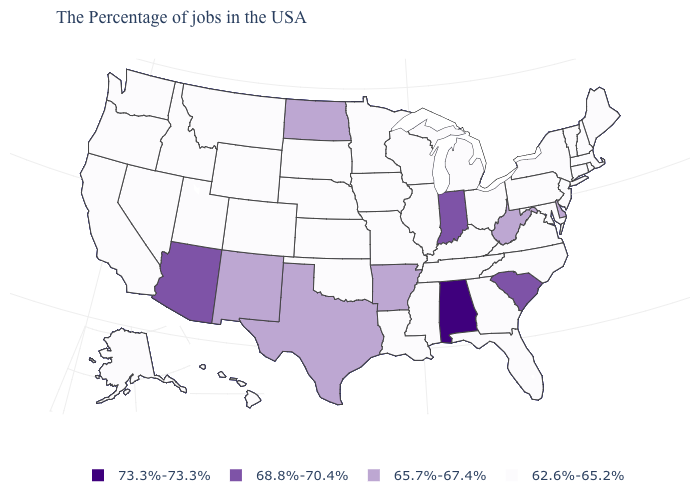What is the value of New Jersey?
Be succinct. 62.6%-65.2%. How many symbols are there in the legend?
Give a very brief answer. 4. What is the value of Arizona?
Answer briefly. 68.8%-70.4%. What is the value of Arizona?
Write a very short answer. 68.8%-70.4%. Does West Virginia have the same value as North Dakota?
Be succinct. Yes. Does Alabama have the highest value in the USA?
Give a very brief answer. Yes. Which states have the lowest value in the USA?
Concise answer only. Maine, Massachusetts, Rhode Island, New Hampshire, Vermont, Connecticut, New York, New Jersey, Maryland, Pennsylvania, Virginia, North Carolina, Ohio, Florida, Georgia, Michigan, Kentucky, Tennessee, Wisconsin, Illinois, Mississippi, Louisiana, Missouri, Minnesota, Iowa, Kansas, Nebraska, Oklahoma, South Dakota, Wyoming, Colorado, Utah, Montana, Idaho, Nevada, California, Washington, Oregon, Alaska, Hawaii. Name the states that have a value in the range 62.6%-65.2%?
Concise answer only. Maine, Massachusetts, Rhode Island, New Hampshire, Vermont, Connecticut, New York, New Jersey, Maryland, Pennsylvania, Virginia, North Carolina, Ohio, Florida, Georgia, Michigan, Kentucky, Tennessee, Wisconsin, Illinois, Mississippi, Louisiana, Missouri, Minnesota, Iowa, Kansas, Nebraska, Oklahoma, South Dakota, Wyoming, Colorado, Utah, Montana, Idaho, Nevada, California, Washington, Oregon, Alaska, Hawaii. What is the value of Vermont?
Answer briefly. 62.6%-65.2%. Name the states that have a value in the range 62.6%-65.2%?
Concise answer only. Maine, Massachusetts, Rhode Island, New Hampshire, Vermont, Connecticut, New York, New Jersey, Maryland, Pennsylvania, Virginia, North Carolina, Ohio, Florida, Georgia, Michigan, Kentucky, Tennessee, Wisconsin, Illinois, Mississippi, Louisiana, Missouri, Minnesota, Iowa, Kansas, Nebraska, Oklahoma, South Dakota, Wyoming, Colorado, Utah, Montana, Idaho, Nevada, California, Washington, Oregon, Alaska, Hawaii. Does the first symbol in the legend represent the smallest category?
Be succinct. No. What is the lowest value in the MidWest?
Keep it brief. 62.6%-65.2%. What is the highest value in the USA?
Give a very brief answer. 73.3%-73.3%. What is the lowest value in the South?
Be succinct. 62.6%-65.2%. 